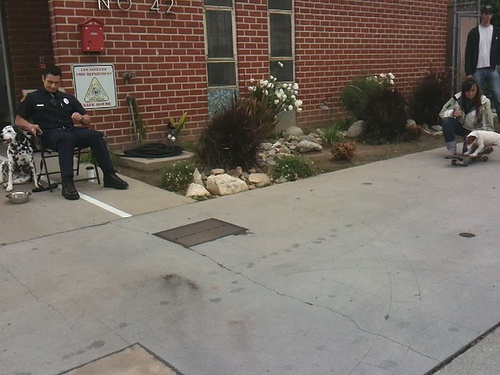Describe the objects in this image and their specific colors. I can see people in black, gray, and maroon tones, people in black, gray, and darkgray tones, people in black, darkgray, and gray tones, dog in black, gray, darkgray, and lightgray tones, and dog in black, darkgray, gray, and lightgray tones in this image. 